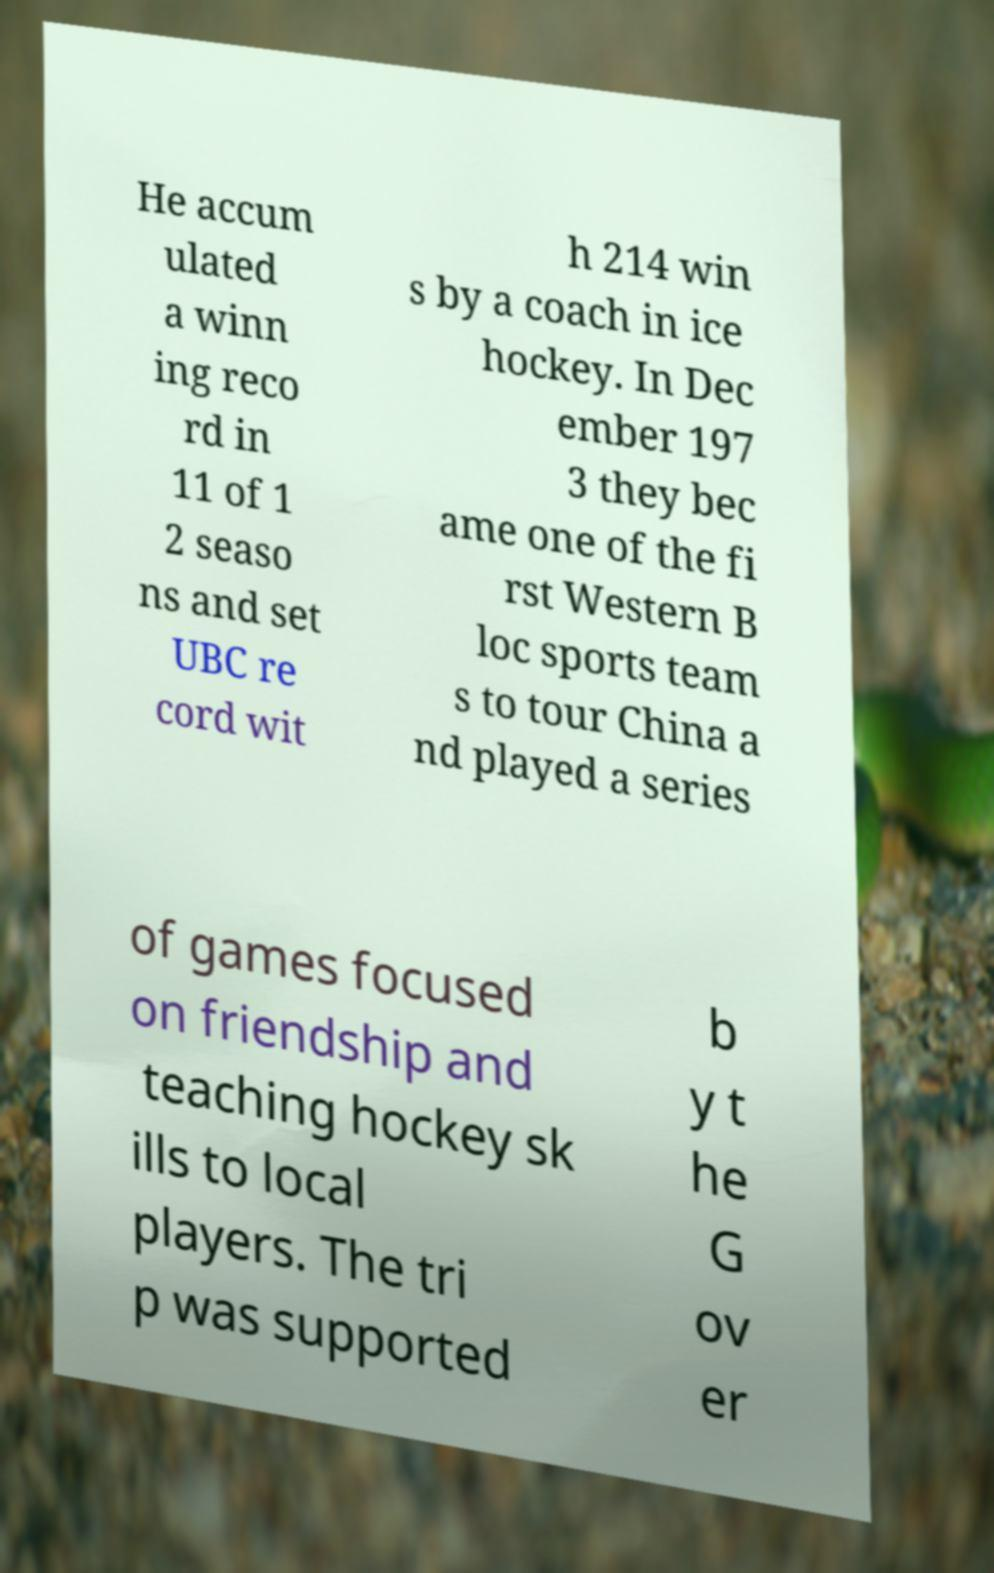I need the written content from this picture converted into text. Can you do that? He accum ulated a winn ing reco rd in 11 of 1 2 seaso ns and set UBC re cord wit h 214 win s by a coach in ice hockey. In Dec ember 197 3 they bec ame one of the fi rst Western B loc sports team s to tour China a nd played a series of games focused on friendship and teaching hockey sk ills to local players. The tri p was supported b y t he G ov er 